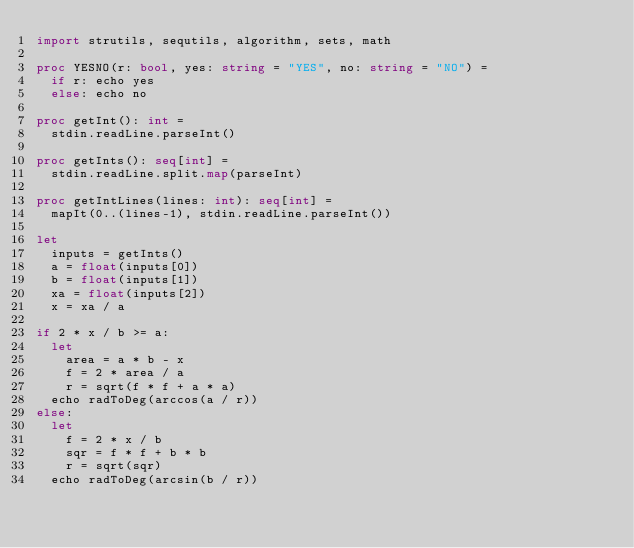<code> <loc_0><loc_0><loc_500><loc_500><_Nim_>import strutils, sequtils, algorithm, sets, math

proc YESNO(r: bool, yes: string = "YES", no: string = "NO") =
  if r: echo yes
  else: echo no

proc getInt(): int =
  stdin.readLine.parseInt()

proc getInts(): seq[int] =
  stdin.readLine.split.map(parseInt)

proc getIntLines(lines: int): seq[int] =
  mapIt(0..(lines-1), stdin.readLine.parseInt())

let
  inputs = getInts()
  a = float(inputs[0])
  b = float(inputs[1])
  xa = float(inputs[2])
  x = xa / a

if 2 * x / b >= a:
  let
    area = a * b - x
    f = 2 * area / a
    r = sqrt(f * f + a * a)
  echo radToDeg(arccos(a / r))
else:
  let
    f = 2 * x / b
    sqr = f * f + b * b
    r = sqrt(sqr)
  echo radToDeg(arcsin(b / r))</code> 